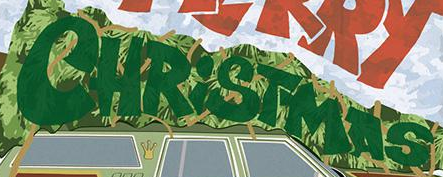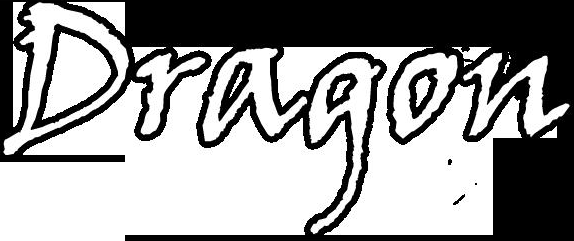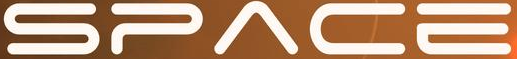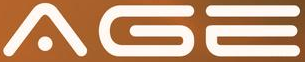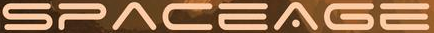Identify the words shown in these images in order, separated by a semicolon. CHRiSTMAS; Dragon; SPACE; AGE; SPACEAGE 